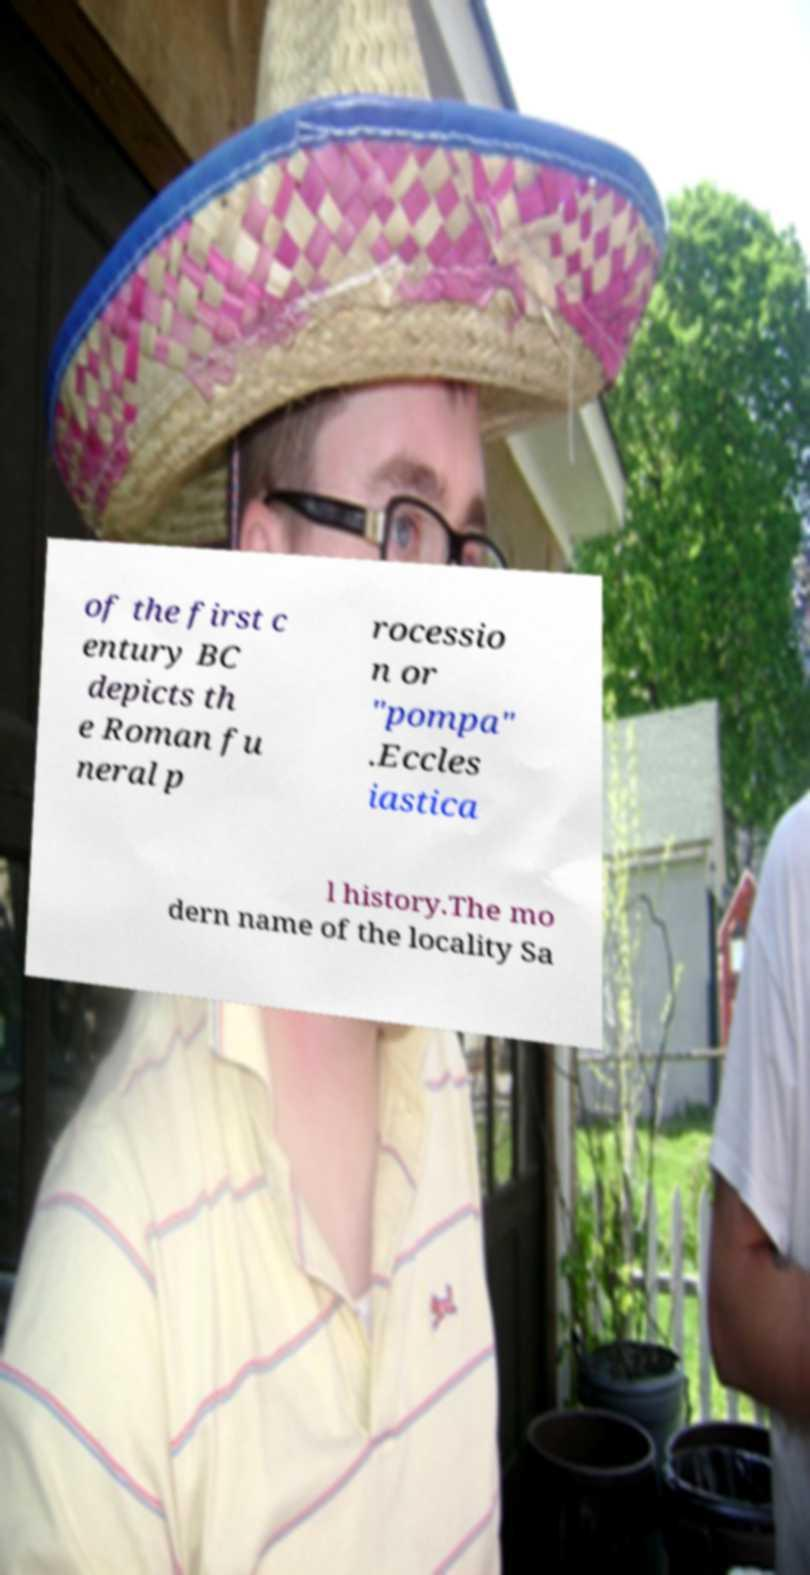What messages or text are displayed in this image? I need them in a readable, typed format. of the first c entury BC depicts th e Roman fu neral p rocessio n or "pompa" .Eccles iastica l history.The mo dern name of the locality Sa 